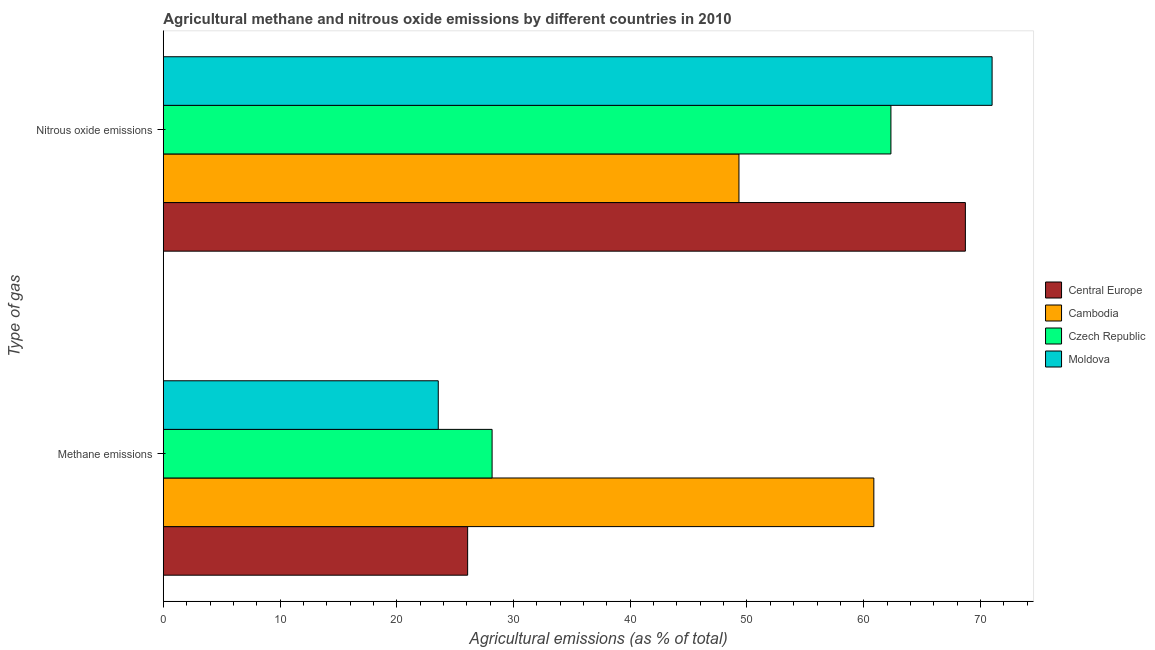How many different coloured bars are there?
Keep it short and to the point. 4. How many groups of bars are there?
Keep it short and to the point. 2. Are the number of bars on each tick of the Y-axis equal?
Ensure brevity in your answer.  Yes. How many bars are there on the 1st tick from the bottom?
Offer a terse response. 4. What is the label of the 2nd group of bars from the top?
Keep it short and to the point. Methane emissions. What is the amount of methane emissions in Cambodia?
Your answer should be very brief. 60.87. Across all countries, what is the maximum amount of nitrous oxide emissions?
Provide a short and direct response. 71. Across all countries, what is the minimum amount of nitrous oxide emissions?
Offer a terse response. 49.31. In which country was the amount of methane emissions maximum?
Offer a terse response. Cambodia. In which country was the amount of methane emissions minimum?
Provide a succinct answer. Moldova. What is the total amount of nitrous oxide emissions in the graph?
Ensure brevity in your answer.  251.35. What is the difference between the amount of nitrous oxide emissions in Moldova and that in Cambodia?
Offer a very short reply. 21.69. What is the difference between the amount of nitrous oxide emissions in Moldova and the amount of methane emissions in Czech Republic?
Offer a very short reply. 42.83. What is the average amount of methane emissions per country?
Offer a very short reply. 34.67. What is the difference between the amount of nitrous oxide emissions and amount of methane emissions in Cambodia?
Ensure brevity in your answer.  -11.56. What is the ratio of the amount of nitrous oxide emissions in Cambodia to that in Moldova?
Keep it short and to the point. 0.69. What does the 3rd bar from the top in Methane emissions represents?
Offer a terse response. Cambodia. What does the 2nd bar from the bottom in Methane emissions represents?
Ensure brevity in your answer.  Cambodia. Does the graph contain any zero values?
Offer a terse response. No. How are the legend labels stacked?
Offer a very short reply. Vertical. What is the title of the graph?
Provide a succinct answer. Agricultural methane and nitrous oxide emissions by different countries in 2010. What is the label or title of the X-axis?
Make the answer very short. Agricultural emissions (as % of total). What is the label or title of the Y-axis?
Provide a succinct answer. Type of gas. What is the Agricultural emissions (as % of total) in Central Europe in Methane emissions?
Your answer should be very brief. 26.07. What is the Agricultural emissions (as % of total) of Cambodia in Methane emissions?
Offer a terse response. 60.87. What is the Agricultural emissions (as % of total) in Czech Republic in Methane emissions?
Provide a succinct answer. 28.17. What is the Agricultural emissions (as % of total) of Moldova in Methane emissions?
Keep it short and to the point. 23.55. What is the Agricultural emissions (as % of total) in Central Europe in Nitrous oxide emissions?
Your answer should be compact. 68.71. What is the Agricultural emissions (as % of total) of Cambodia in Nitrous oxide emissions?
Offer a very short reply. 49.31. What is the Agricultural emissions (as % of total) in Czech Republic in Nitrous oxide emissions?
Offer a very short reply. 62.33. What is the Agricultural emissions (as % of total) in Moldova in Nitrous oxide emissions?
Your response must be concise. 71. Across all Type of gas, what is the maximum Agricultural emissions (as % of total) in Central Europe?
Give a very brief answer. 68.71. Across all Type of gas, what is the maximum Agricultural emissions (as % of total) of Cambodia?
Your answer should be compact. 60.87. Across all Type of gas, what is the maximum Agricultural emissions (as % of total) in Czech Republic?
Give a very brief answer. 62.33. Across all Type of gas, what is the maximum Agricultural emissions (as % of total) in Moldova?
Offer a very short reply. 71. Across all Type of gas, what is the minimum Agricultural emissions (as % of total) in Central Europe?
Offer a terse response. 26.07. Across all Type of gas, what is the minimum Agricultural emissions (as % of total) in Cambodia?
Your answer should be very brief. 49.31. Across all Type of gas, what is the minimum Agricultural emissions (as % of total) of Czech Republic?
Ensure brevity in your answer.  28.17. Across all Type of gas, what is the minimum Agricultural emissions (as % of total) of Moldova?
Keep it short and to the point. 23.55. What is the total Agricultural emissions (as % of total) in Central Europe in the graph?
Make the answer very short. 94.78. What is the total Agricultural emissions (as % of total) of Cambodia in the graph?
Offer a terse response. 110.18. What is the total Agricultural emissions (as % of total) in Czech Republic in the graph?
Keep it short and to the point. 90.5. What is the total Agricultural emissions (as % of total) in Moldova in the graph?
Offer a very short reply. 94.55. What is the difference between the Agricultural emissions (as % of total) in Central Europe in Methane emissions and that in Nitrous oxide emissions?
Your answer should be very brief. -42.64. What is the difference between the Agricultural emissions (as % of total) of Cambodia in Methane emissions and that in Nitrous oxide emissions?
Ensure brevity in your answer.  11.56. What is the difference between the Agricultural emissions (as % of total) of Czech Republic in Methane emissions and that in Nitrous oxide emissions?
Offer a very short reply. -34.17. What is the difference between the Agricultural emissions (as % of total) in Moldova in Methane emissions and that in Nitrous oxide emissions?
Make the answer very short. -47.44. What is the difference between the Agricultural emissions (as % of total) in Central Europe in Methane emissions and the Agricultural emissions (as % of total) in Cambodia in Nitrous oxide emissions?
Provide a succinct answer. -23.24. What is the difference between the Agricultural emissions (as % of total) of Central Europe in Methane emissions and the Agricultural emissions (as % of total) of Czech Republic in Nitrous oxide emissions?
Provide a short and direct response. -36.26. What is the difference between the Agricultural emissions (as % of total) of Central Europe in Methane emissions and the Agricultural emissions (as % of total) of Moldova in Nitrous oxide emissions?
Offer a very short reply. -44.93. What is the difference between the Agricultural emissions (as % of total) of Cambodia in Methane emissions and the Agricultural emissions (as % of total) of Czech Republic in Nitrous oxide emissions?
Ensure brevity in your answer.  -1.46. What is the difference between the Agricultural emissions (as % of total) in Cambodia in Methane emissions and the Agricultural emissions (as % of total) in Moldova in Nitrous oxide emissions?
Ensure brevity in your answer.  -10.13. What is the difference between the Agricultural emissions (as % of total) of Czech Republic in Methane emissions and the Agricultural emissions (as % of total) of Moldova in Nitrous oxide emissions?
Ensure brevity in your answer.  -42.83. What is the average Agricultural emissions (as % of total) in Central Europe per Type of gas?
Make the answer very short. 47.39. What is the average Agricultural emissions (as % of total) of Cambodia per Type of gas?
Ensure brevity in your answer.  55.09. What is the average Agricultural emissions (as % of total) in Czech Republic per Type of gas?
Your answer should be very brief. 45.25. What is the average Agricultural emissions (as % of total) of Moldova per Type of gas?
Your answer should be compact. 47.28. What is the difference between the Agricultural emissions (as % of total) of Central Europe and Agricultural emissions (as % of total) of Cambodia in Methane emissions?
Give a very brief answer. -34.8. What is the difference between the Agricultural emissions (as % of total) of Central Europe and Agricultural emissions (as % of total) of Czech Republic in Methane emissions?
Your answer should be compact. -2.09. What is the difference between the Agricultural emissions (as % of total) of Central Europe and Agricultural emissions (as % of total) of Moldova in Methane emissions?
Ensure brevity in your answer.  2.52. What is the difference between the Agricultural emissions (as % of total) in Cambodia and Agricultural emissions (as % of total) in Czech Republic in Methane emissions?
Offer a terse response. 32.7. What is the difference between the Agricultural emissions (as % of total) in Cambodia and Agricultural emissions (as % of total) in Moldova in Methane emissions?
Offer a terse response. 37.31. What is the difference between the Agricultural emissions (as % of total) of Czech Republic and Agricultural emissions (as % of total) of Moldova in Methane emissions?
Give a very brief answer. 4.61. What is the difference between the Agricultural emissions (as % of total) in Central Europe and Agricultural emissions (as % of total) in Cambodia in Nitrous oxide emissions?
Keep it short and to the point. 19.4. What is the difference between the Agricultural emissions (as % of total) of Central Europe and Agricultural emissions (as % of total) of Czech Republic in Nitrous oxide emissions?
Ensure brevity in your answer.  6.38. What is the difference between the Agricultural emissions (as % of total) of Central Europe and Agricultural emissions (as % of total) of Moldova in Nitrous oxide emissions?
Offer a terse response. -2.29. What is the difference between the Agricultural emissions (as % of total) of Cambodia and Agricultural emissions (as % of total) of Czech Republic in Nitrous oxide emissions?
Give a very brief answer. -13.02. What is the difference between the Agricultural emissions (as % of total) of Cambodia and Agricultural emissions (as % of total) of Moldova in Nitrous oxide emissions?
Offer a very short reply. -21.69. What is the difference between the Agricultural emissions (as % of total) in Czech Republic and Agricultural emissions (as % of total) in Moldova in Nitrous oxide emissions?
Make the answer very short. -8.67. What is the ratio of the Agricultural emissions (as % of total) in Central Europe in Methane emissions to that in Nitrous oxide emissions?
Make the answer very short. 0.38. What is the ratio of the Agricultural emissions (as % of total) in Cambodia in Methane emissions to that in Nitrous oxide emissions?
Make the answer very short. 1.23. What is the ratio of the Agricultural emissions (as % of total) in Czech Republic in Methane emissions to that in Nitrous oxide emissions?
Offer a terse response. 0.45. What is the ratio of the Agricultural emissions (as % of total) of Moldova in Methane emissions to that in Nitrous oxide emissions?
Make the answer very short. 0.33. What is the difference between the highest and the second highest Agricultural emissions (as % of total) of Central Europe?
Your answer should be compact. 42.64. What is the difference between the highest and the second highest Agricultural emissions (as % of total) in Cambodia?
Your response must be concise. 11.56. What is the difference between the highest and the second highest Agricultural emissions (as % of total) of Czech Republic?
Offer a terse response. 34.17. What is the difference between the highest and the second highest Agricultural emissions (as % of total) of Moldova?
Your answer should be compact. 47.44. What is the difference between the highest and the lowest Agricultural emissions (as % of total) of Central Europe?
Give a very brief answer. 42.64. What is the difference between the highest and the lowest Agricultural emissions (as % of total) in Cambodia?
Keep it short and to the point. 11.56. What is the difference between the highest and the lowest Agricultural emissions (as % of total) of Czech Republic?
Your answer should be very brief. 34.17. What is the difference between the highest and the lowest Agricultural emissions (as % of total) in Moldova?
Keep it short and to the point. 47.44. 